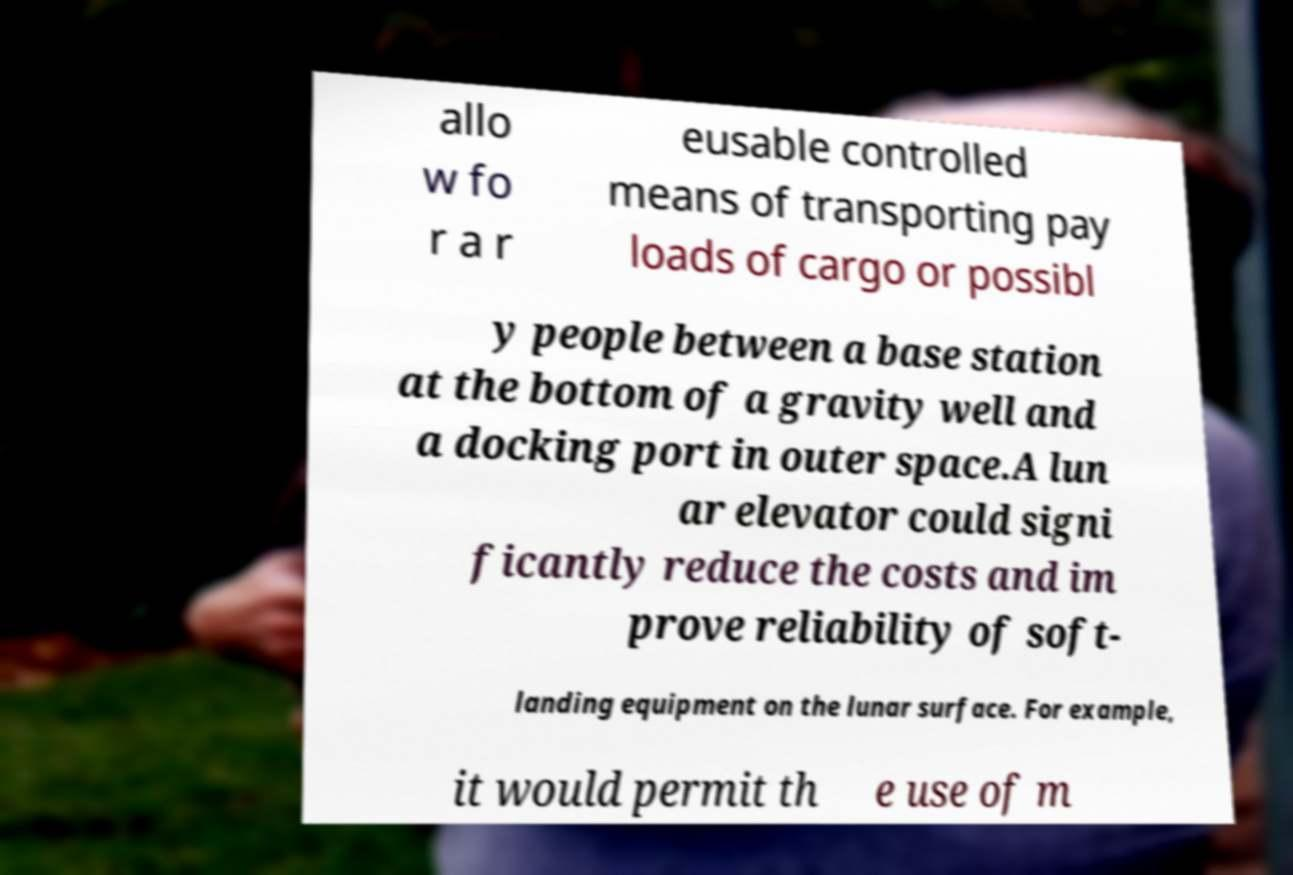Can you accurately transcribe the text from the provided image for me? allo w fo r a r eusable controlled means of transporting pay loads of cargo or possibl y people between a base station at the bottom of a gravity well and a docking port in outer space.A lun ar elevator could signi ficantly reduce the costs and im prove reliability of soft- landing equipment on the lunar surface. For example, it would permit th e use of m 